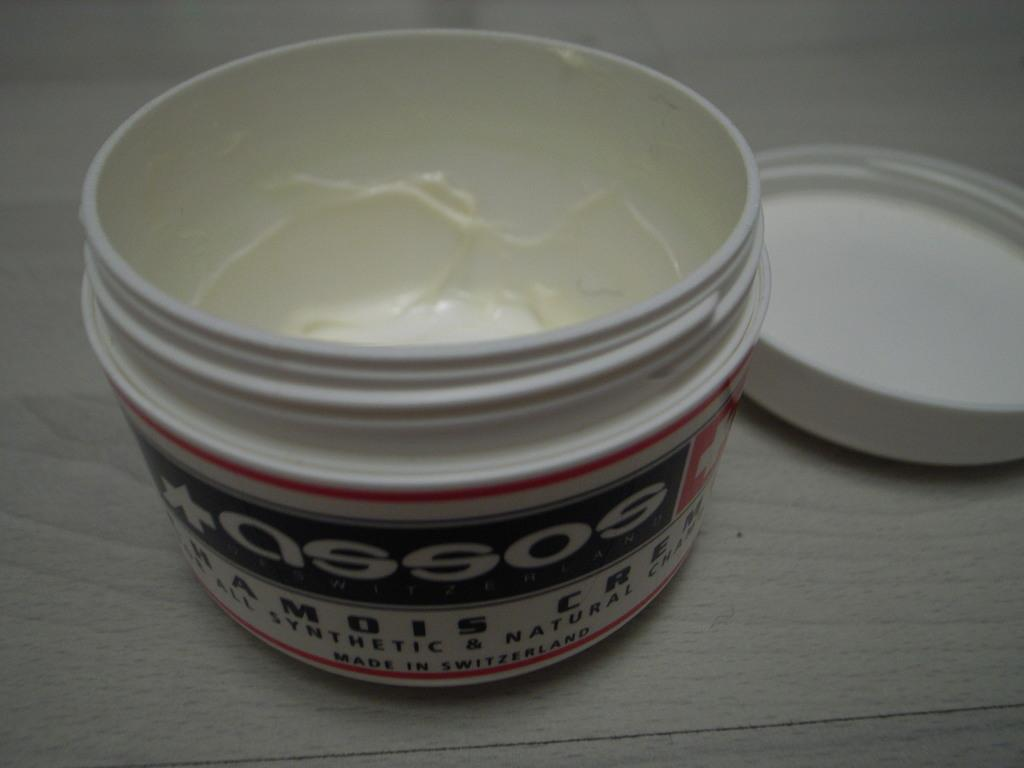<image>
Render a clear and concise summary of the photo. A jar of assos cream is nearly empty and sits with the lid off. 